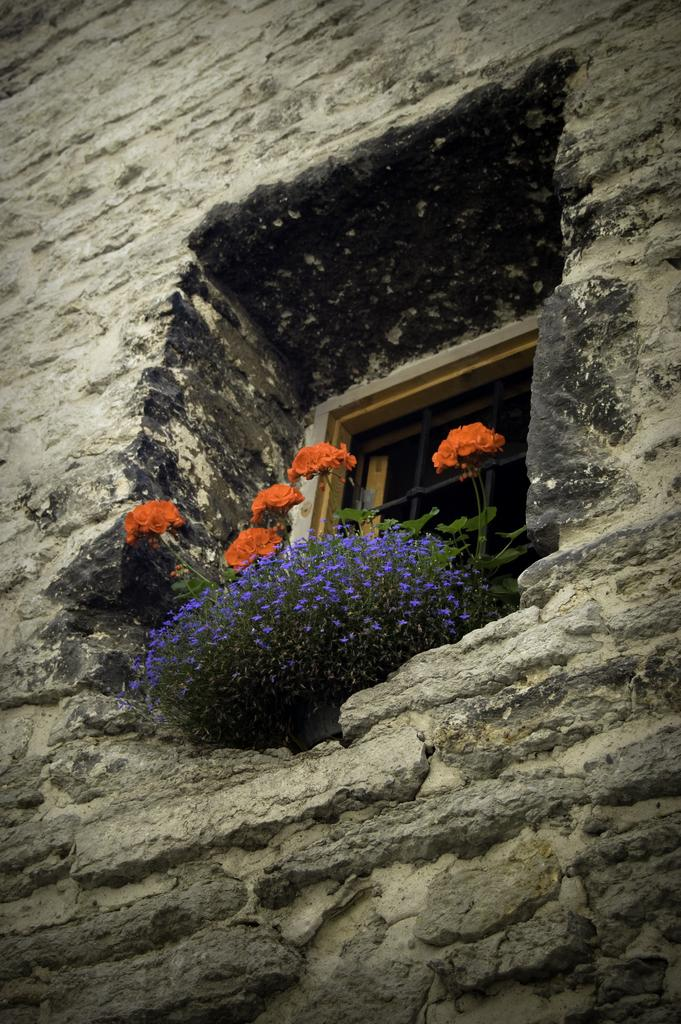What is located in the center of the image? There is a window in the center of the image. What can be seen through the window? The provided facts do not mention what can be seen through the window. What is placed in front of the window? There are flowers in front of the window. What type of rifle is being used by the actor in the image? There is no actor or rifle present in the image; it features a window and flowers. 